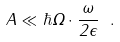Convert formula to latex. <formula><loc_0><loc_0><loc_500><loc_500>A \ll \hbar { \Omega } \cdot \frac { \omega } { 2 \epsilon } \ .</formula> 